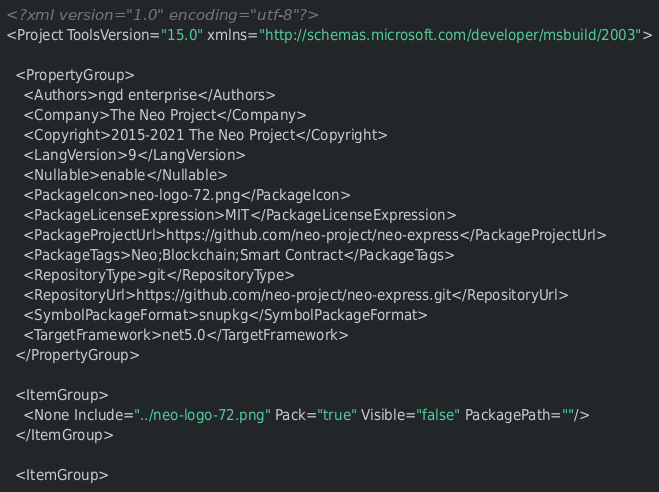Convert code to text. <code><loc_0><loc_0><loc_500><loc_500><_XML_><?xml version="1.0" encoding="utf-8"?>
<Project ToolsVersion="15.0" xmlns="http://schemas.microsoft.com/developer/msbuild/2003">

  <PropertyGroup>
    <Authors>ngd enterprise</Authors>
    <Company>The Neo Project</Company>
    <Copyright>2015-2021 The Neo Project</Copyright>
    <LangVersion>9</LangVersion>
    <Nullable>enable</Nullable>
    <PackageIcon>neo-logo-72.png</PackageIcon>
    <PackageLicenseExpression>MIT</PackageLicenseExpression>
    <PackageProjectUrl>https://github.com/neo-project/neo-express</PackageProjectUrl>
    <PackageTags>Neo;Blockchain;Smart Contract</PackageTags>
    <RepositoryType>git</RepositoryType>
    <RepositoryUrl>https://github.com/neo-project/neo-express.git</RepositoryUrl>
    <SymbolPackageFormat>snupkg</SymbolPackageFormat>
    <TargetFramework>net5.0</TargetFramework>
  </PropertyGroup>

  <ItemGroup>
    <None Include="../neo-logo-72.png" Pack="true" Visible="false" PackagePath=""/>
  </ItemGroup>

  <ItemGroup></code> 